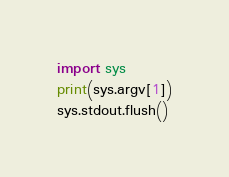Convert code to text. <code><loc_0><loc_0><loc_500><loc_500><_Python_>import sys
print(sys.argv[1])
sys.stdout.flush()
</code> 